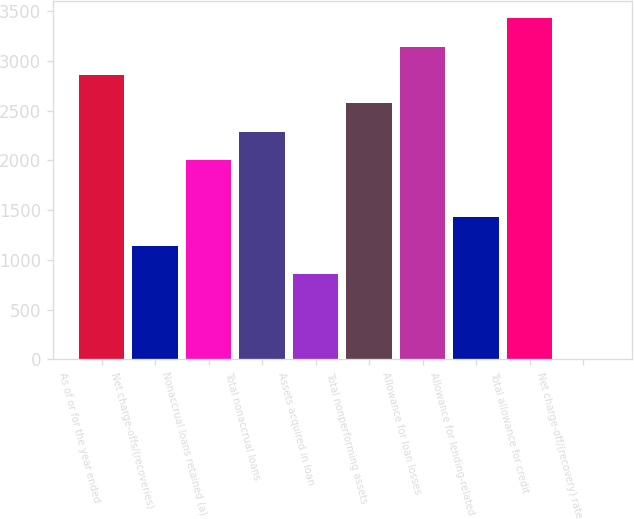Convert chart. <chart><loc_0><loc_0><loc_500><loc_500><bar_chart><fcel>As of or for the year ended<fcel>Net charge-offs/(recoveries)<fcel>Nonaccrual loans retained (a)<fcel>Total nonaccrual loans<fcel>Assets acquired in loan<fcel>Total nonperforming assets<fcel>Allowance for loan losses<fcel>Allowance for lending-related<fcel>Total allowance for credit<fcel>Net charge-off/(recovery) rate<nl><fcel>2858.02<fcel>1143.22<fcel>2000.62<fcel>2286.42<fcel>857.42<fcel>2572.22<fcel>3143.82<fcel>1429.02<fcel>3429.62<fcel>0.02<nl></chart> 